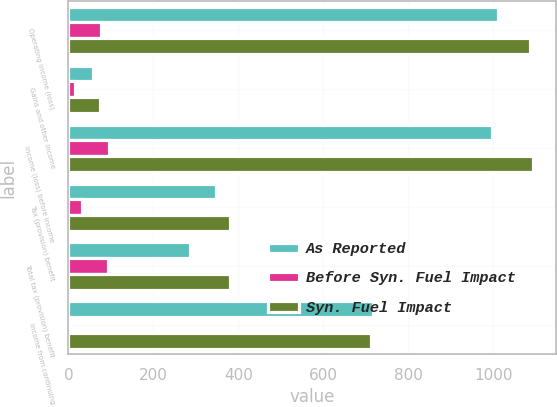Convert chart. <chart><loc_0><loc_0><loc_500><loc_500><stacked_bar_chart><ecel><fcel>Operating income (loss)<fcel>Gains and other income<fcel>Income (loss) before income<fcel>Tax (provision) benefit<fcel>Total tax (provision) benefit<fcel>Income from continuing<nl><fcel>As Reported<fcel>1011<fcel>59<fcel>997<fcel>348<fcel>286<fcel>717<nl><fcel>Before Syn. Fuel Impact<fcel>76<fcel>15<fcel>95<fcel>32<fcel>94<fcel>5<nl><fcel>Syn. Fuel Impact<fcel>1087<fcel>74<fcel>1092<fcel>380<fcel>380<fcel>712<nl></chart> 